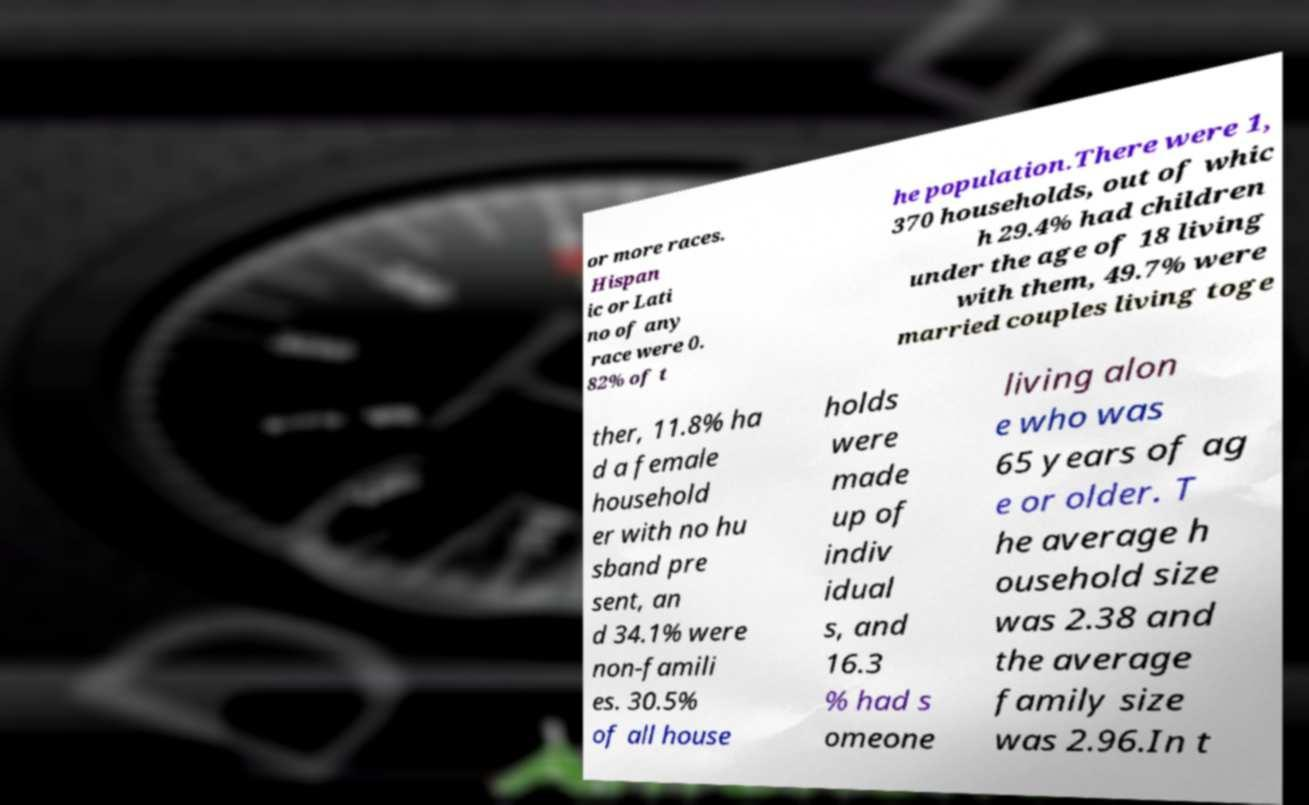Please identify and transcribe the text found in this image. or more races. Hispan ic or Lati no of any race were 0. 82% of t he population.There were 1, 370 households, out of whic h 29.4% had children under the age of 18 living with them, 49.7% were married couples living toge ther, 11.8% ha d a female household er with no hu sband pre sent, an d 34.1% were non-famili es. 30.5% of all house holds were made up of indiv idual s, and 16.3 % had s omeone living alon e who was 65 years of ag e or older. T he average h ousehold size was 2.38 and the average family size was 2.96.In t 